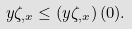<formula> <loc_0><loc_0><loc_500><loc_500>y \zeta _ { , x } \leq \left ( y \zeta _ { , x } \right ) ( 0 ) .</formula> 